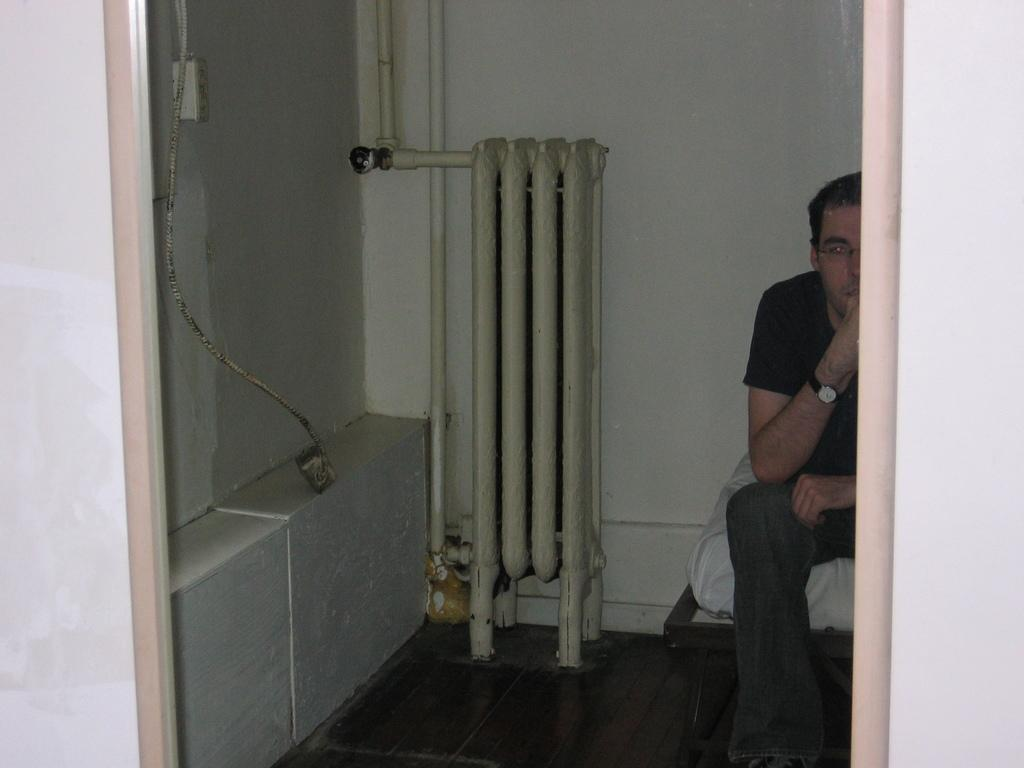What is the main subject of the image? There is a man in the image. What is the man wearing? The man is wearing a black t-shirt. Where is the man located in the image? The man is sitting on a bed. What can be seen in front of the wall in the image? There are pipes in front of a wall in the image. How does the man's feeling about the cream affect the image? There is no mention of cream or the man's feelings in the image, so it cannot affect the image. 